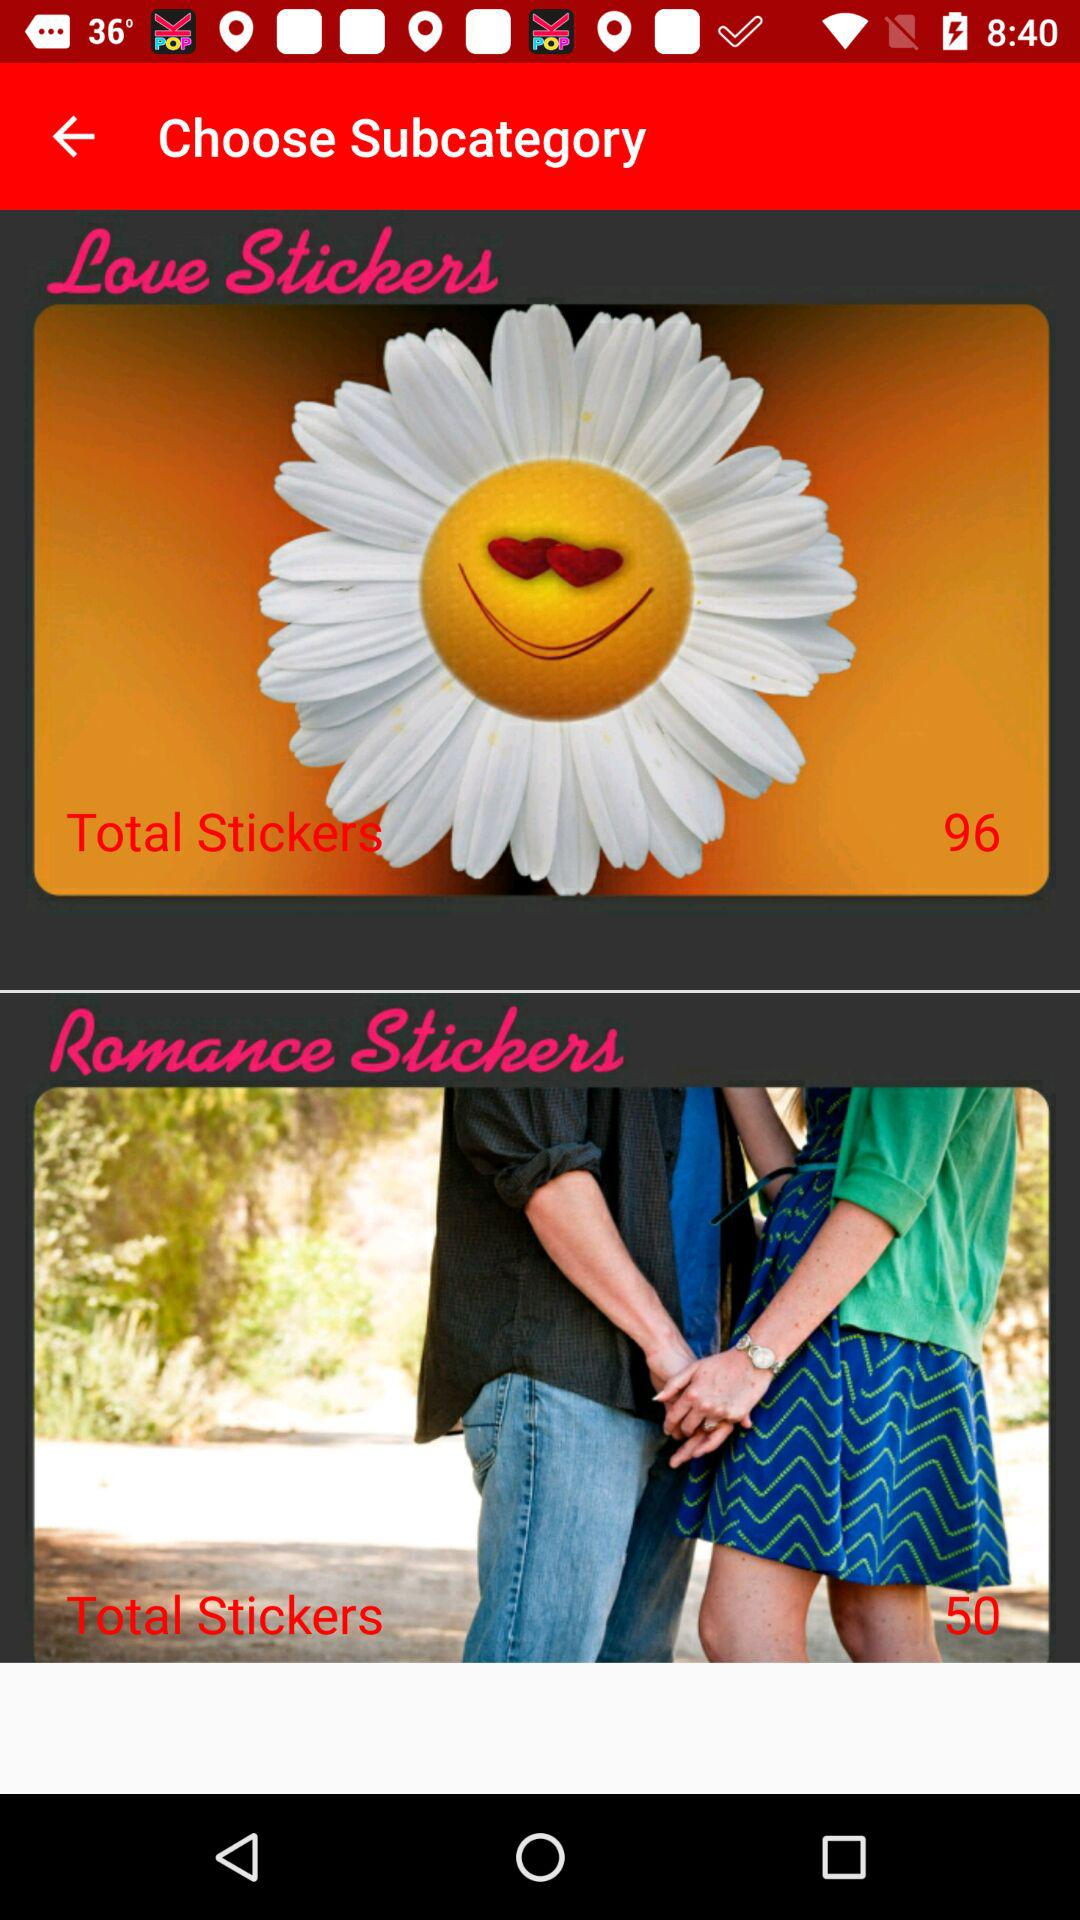What is the total number of romance stickers? The total number of romance stickers is 50. 